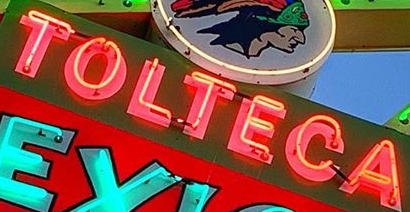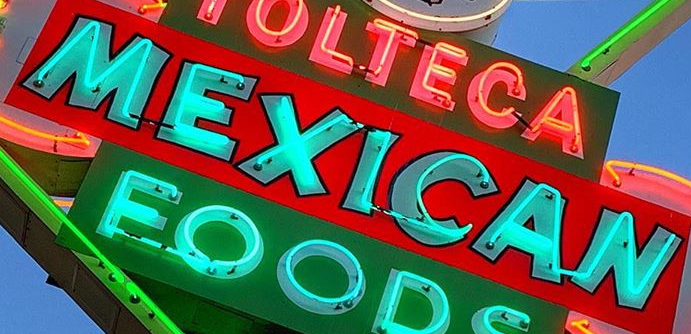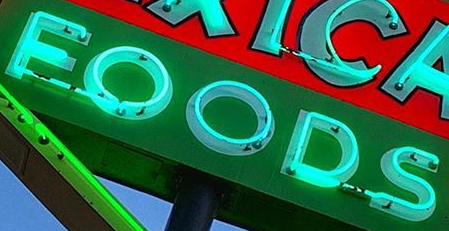What text is displayed in these images sequentially, separated by a semicolon? TOLTECA; MEXICAN; FOODS 